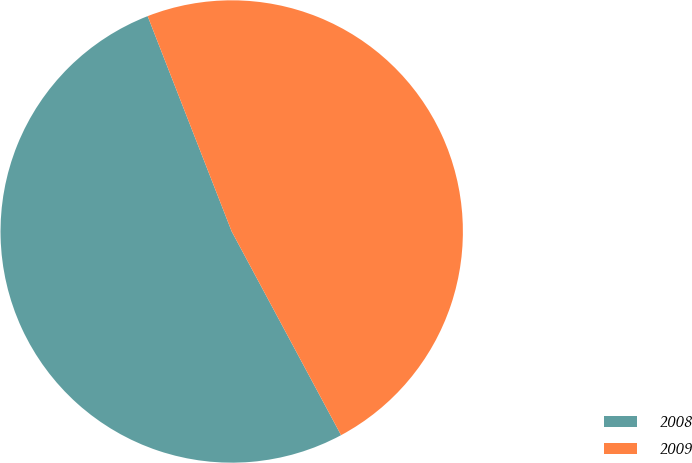<chart> <loc_0><loc_0><loc_500><loc_500><pie_chart><fcel>2008<fcel>2009<nl><fcel>51.92%<fcel>48.08%<nl></chart> 